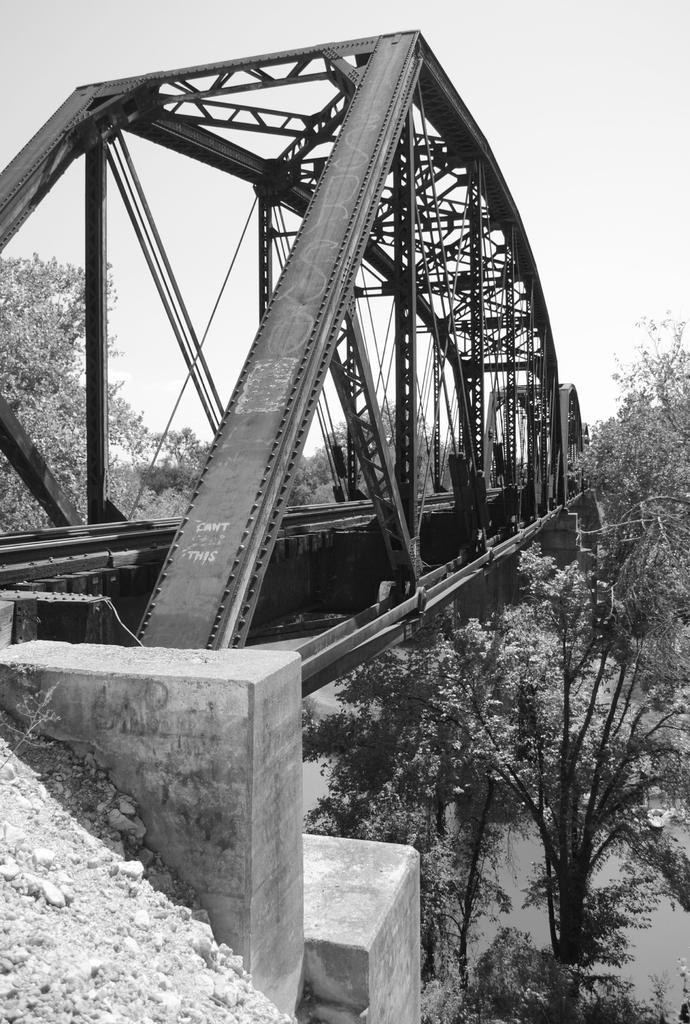Please provide a concise description of this image. In this image I can see a bridge in the centre and on it I can see something is written in the front. On the both side of this bridge I can see number of trees and I can see this image is black and white in colour. 